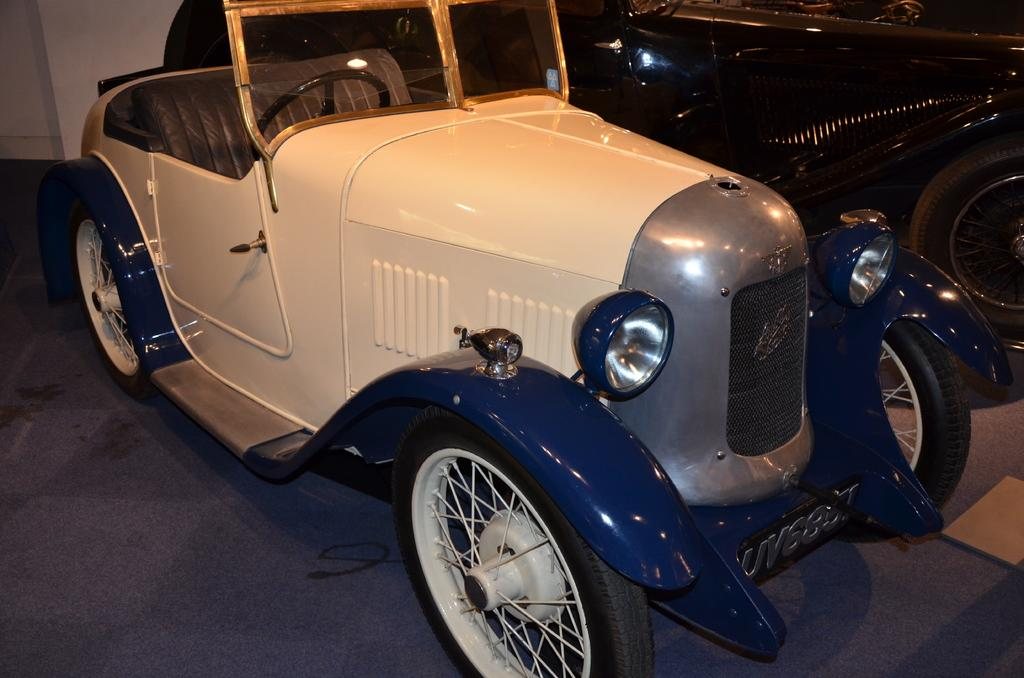What is the main subject of the image? There is a vehicle in the image. Can you describe the color of the vehicle? The vehicle is white in color. What can be seen in the background of the image? There is a wall in the background of the image. What type of plant is being used for the selection process in the image? There is no plant or selection process present in the image; it features a white vehicle and a wall in the background. 